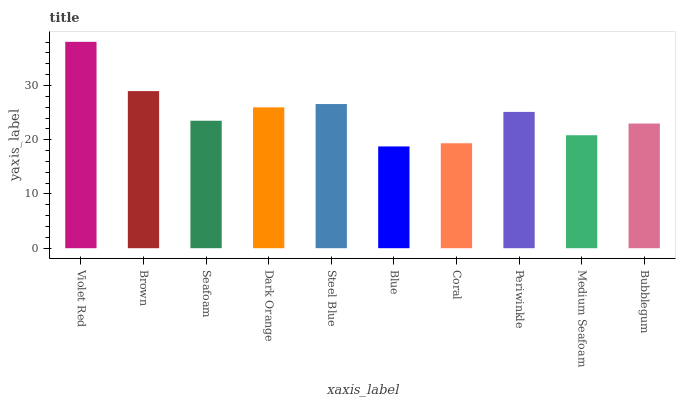Is Brown the minimum?
Answer yes or no. No. Is Brown the maximum?
Answer yes or no. No. Is Violet Red greater than Brown?
Answer yes or no. Yes. Is Brown less than Violet Red?
Answer yes or no. Yes. Is Brown greater than Violet Red?
Answer yes or no. No. Is Violet Red less than Brown?
Answer yes or no. No. Is Periwinkle the high median?
Answer yes or no. Yes. Is Seafoam the low median?
Answer yes or no. Yes. Is Brown the high median?
Answer yes or no. No. Is Dark Orange the low median?
Answer yes or no. No. 